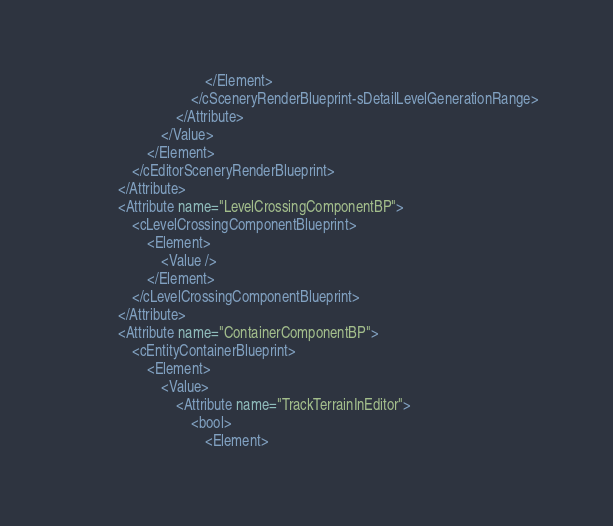Convert code to text. <code><loc_0><loc_0><loc_500><loc_500><_XML_>									</Element>
								</cSceneryRenderBlueprint-sDetailLevelGenerationRange>
							</Attribute>
						</Value>
					</Element>
				</cEditorSceneryRenderBlueprint>
			</Attribute>
			<Attribute name="LevelCrossingComponentBP">
				<cLevelCrossingComponentBlueprint>
					<Element>
						<Value />
					</Element>
				</cLevelCrossingComponentBlueprint>
			</Attribute>
			<Attribute name="ContainerComponentBP">
				<cEntityContainerBlueprint>
					<Element>
						<Value>
							<Attribute name="TrackTerrainInEditor">
								<bool>
									<Element></code> 